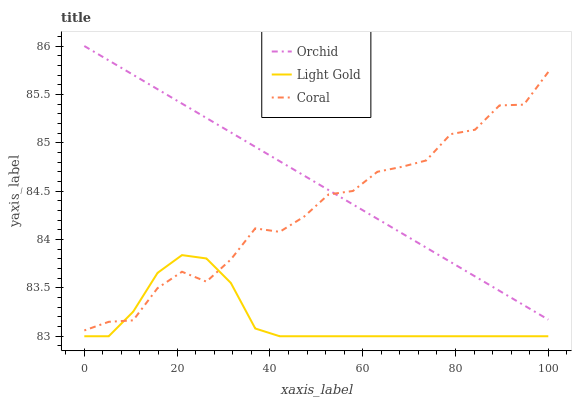Does Light Gold have the minimum area under the curve?
Answer yes or no. Yes. Does Orchid have the maximum area under the curve?
Answer yes or no. Yes. Does Orchid have the minimum area under the curve?
Answer yes or no. No. Does Light Gold have the maximum area under the curve?
Answer yes or no. No. Is Orchid the smoothest?
Answer yes or no. Yes. Is Coral the roughest?
Answer yes or no. Yes. Is Light Gold the smoothest?
Answer yes or no. No. Is Light Gold the roughest?
Answer yes or no. No. Does Light Gold have the lowest value?
Answer yes or no. Yes. Does Orchid have the lowest value?
Answer yes or no. No. Does Orchid have the highest value?
Answer yes or no. Yes. Does Light Gold have the highest value?
Answer yes or no. No. Is Light Gold less than Orchid?
Answer yes or no. Yes. Is Orchid greater than Light Gold?
Answer yes or no. Yes. Does Orchid intersect Coral?
Answer yes or no. Yes. Is Orchid less than Coral?
Answer yes or no. No. Is Orchid greater than Coral?
Answer yes or no. No. Does Light Gold intersect Orchid?
Answer yes or no. No. 